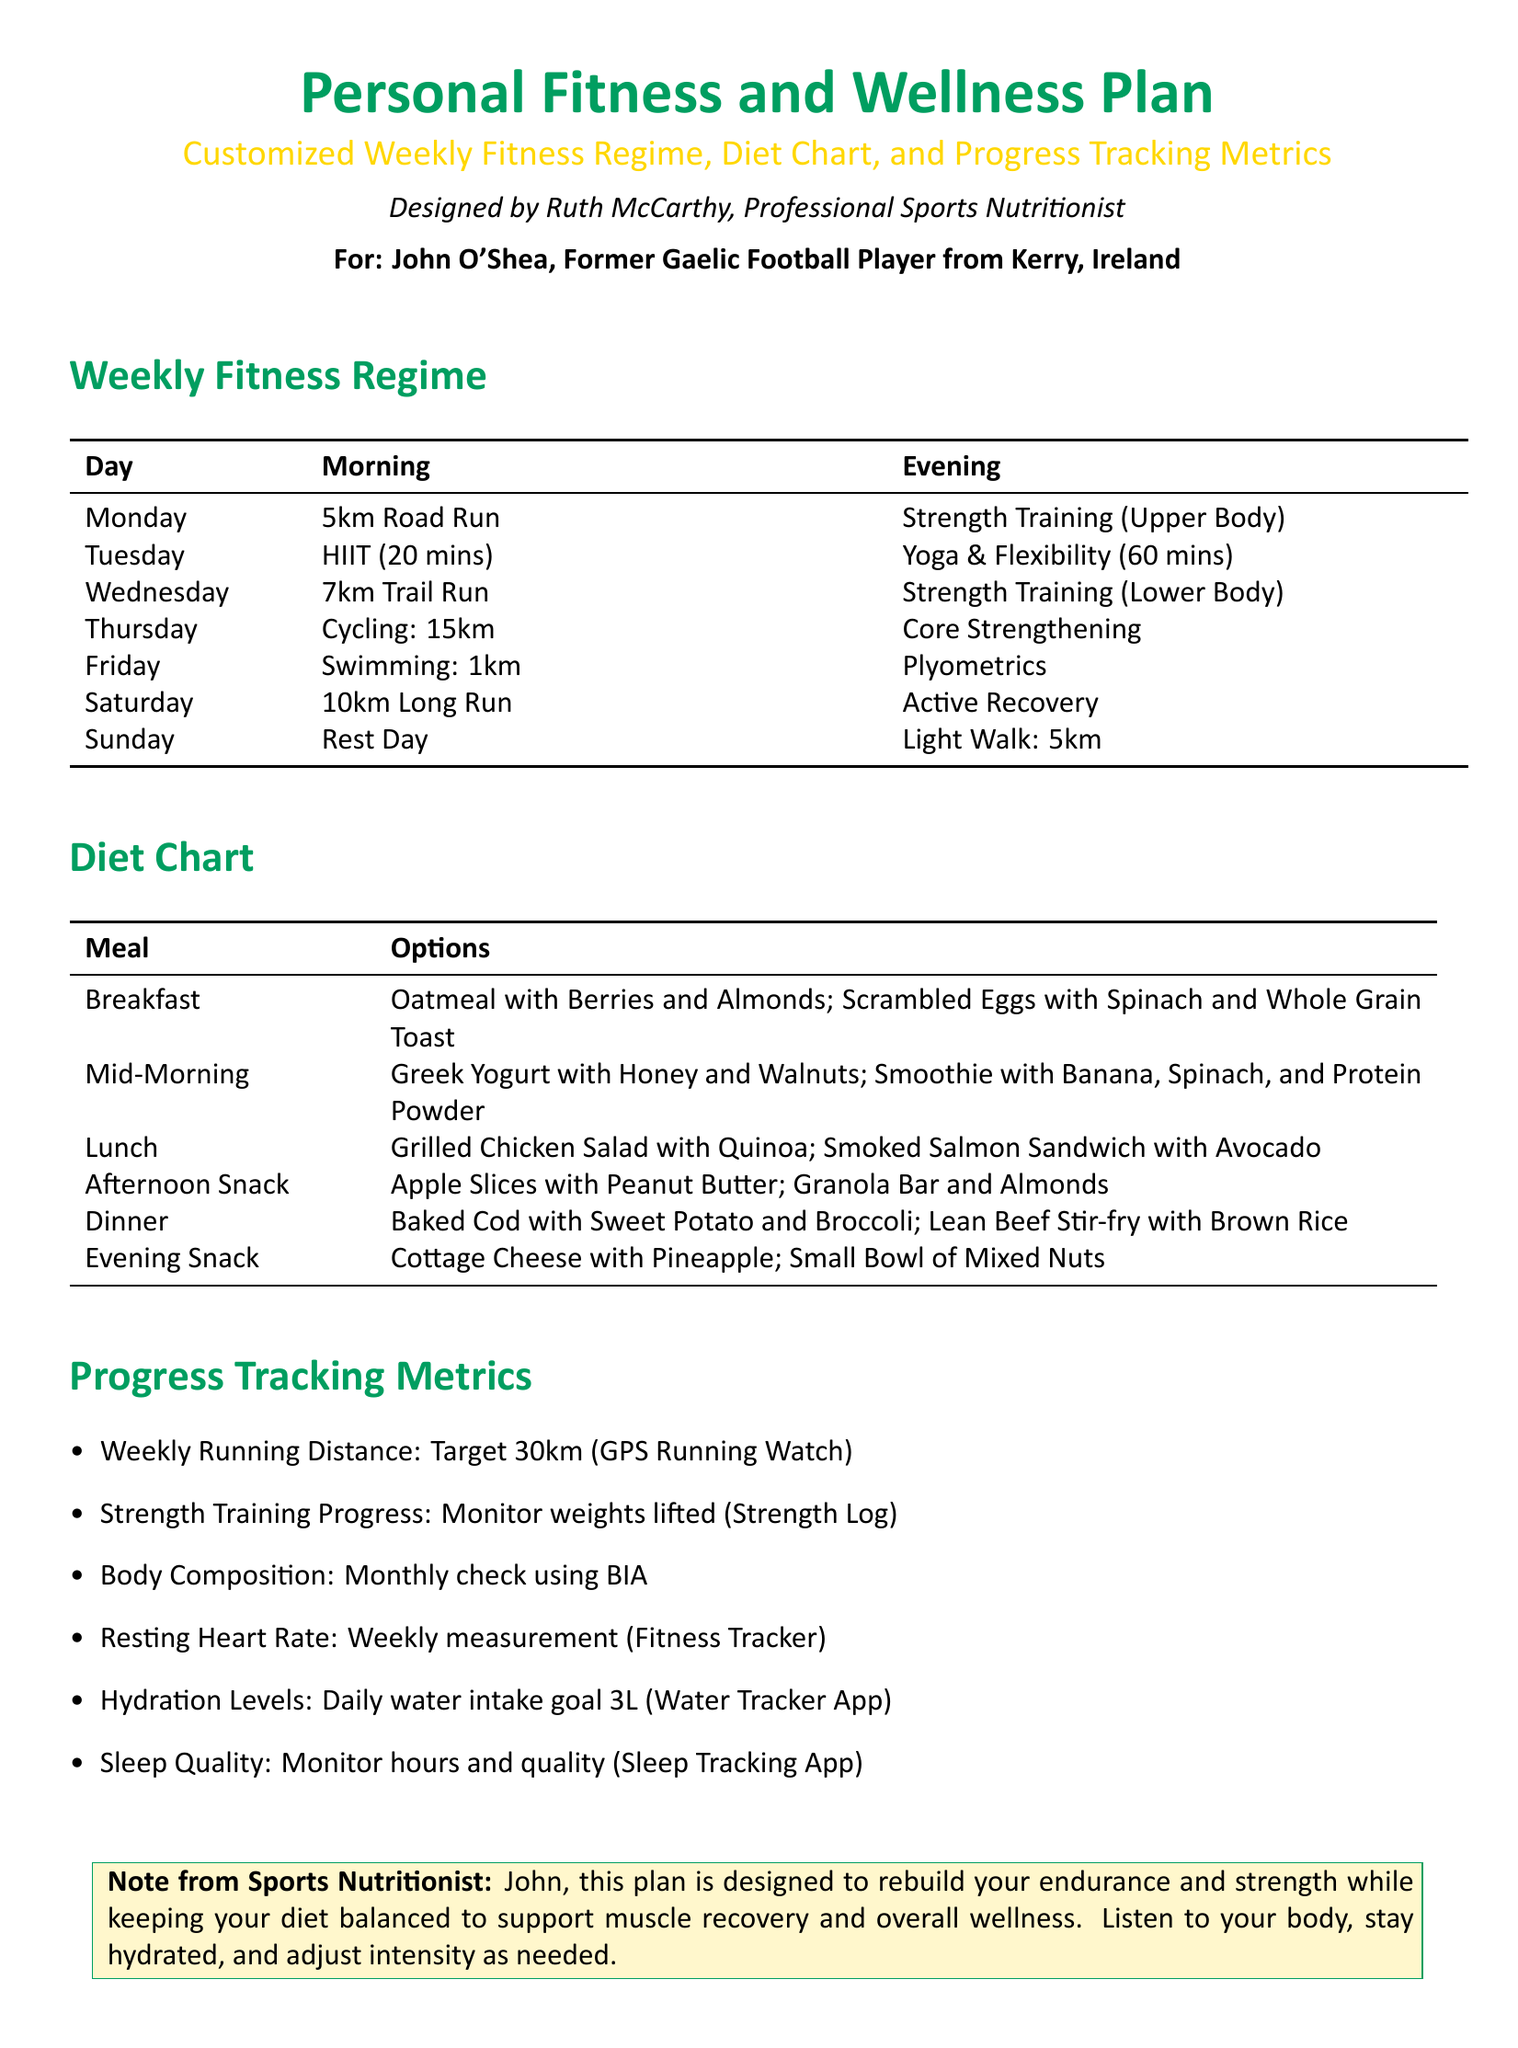What is the name of the professional sports nutritionist? The document specifies that the plan is designed by Ruth McCarthy, who is a professional sports nutritionist.
Answer: Ruth McCarthy What is the target distance for weekly running? The document states the target for weekly running distance is 30km, as tracked with a GPS running watch.
Answer: 30km What type of training is scheduled for Tuesday morning? The document outlines that the Tuesday morning training is HIIT, which lasts for 20 minutes.
Answer: HIIT What is included in the evening snack options? The document lists cottage cheese with pineapple and a small bowl of mixed nuts as evening snack options.
Answer: Cottage cheese with pineapple; Small bowl of mixed nuts What should the hydration goal be according to the plan? The hydration goal mentioned in the document is daily water intake of 3 liters, which can be tracked using a water tracker app.
Answer: 3L How many kilometers are scheduled for the Saturday run? The document specifies that there is a 10km long run scheduled for Saturday.
Answer: 10km What should be monitored monthly for body composition? The document mentions that body composition should be checked monthly using BIA.
Answer: BIA What is the purpose of the personal fitness and wellness plan? The note from the sports nutritionist indicates that the plan aims to rebuild endurance and strength while supporting muscle recovery and wellness.
Answer: Rebuild endurance and strength What type of workout is included in Friday's evening training? The document indicates that plyometrics is the scheduled evening workout for Friday.
Answer: Plyometrics 